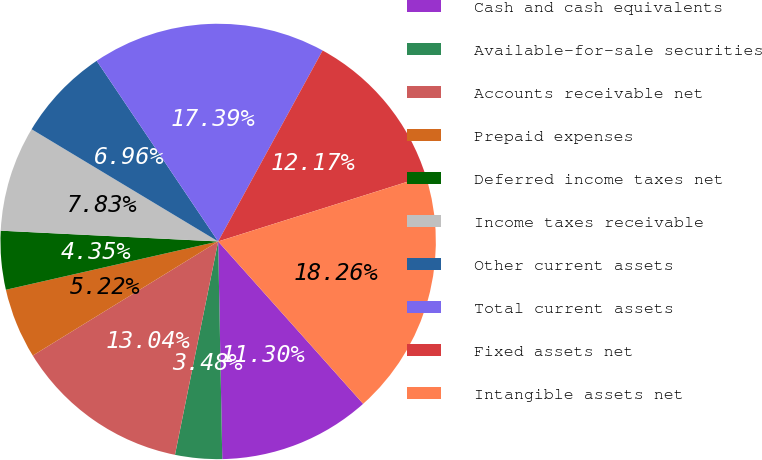Convert chart to OTSL. <chart><loc_0><loc_0><loc_500><loc_500><pie_chart><fcel>Cash and cash equivalents<fcel>Available-for-sale securities<fcel>Accounts receivable net<fcel>Prepaid expenses<fcel>Deferred income taxes net<fcel>Income taxes receivable<fcel>Other current assets<fcel>Total current assets<fcel>Fixed assets net<fcel>Intangible assets net<nl><fcel>11.3%<fcel>3.48%<fcel>13.04%<fcel>5.22%<fcel>4.35%<fcel>7.83%<fcel>6.96%<fcel>17.39%<fcel>12.17%<fcel>18.26%<nl></chart> 